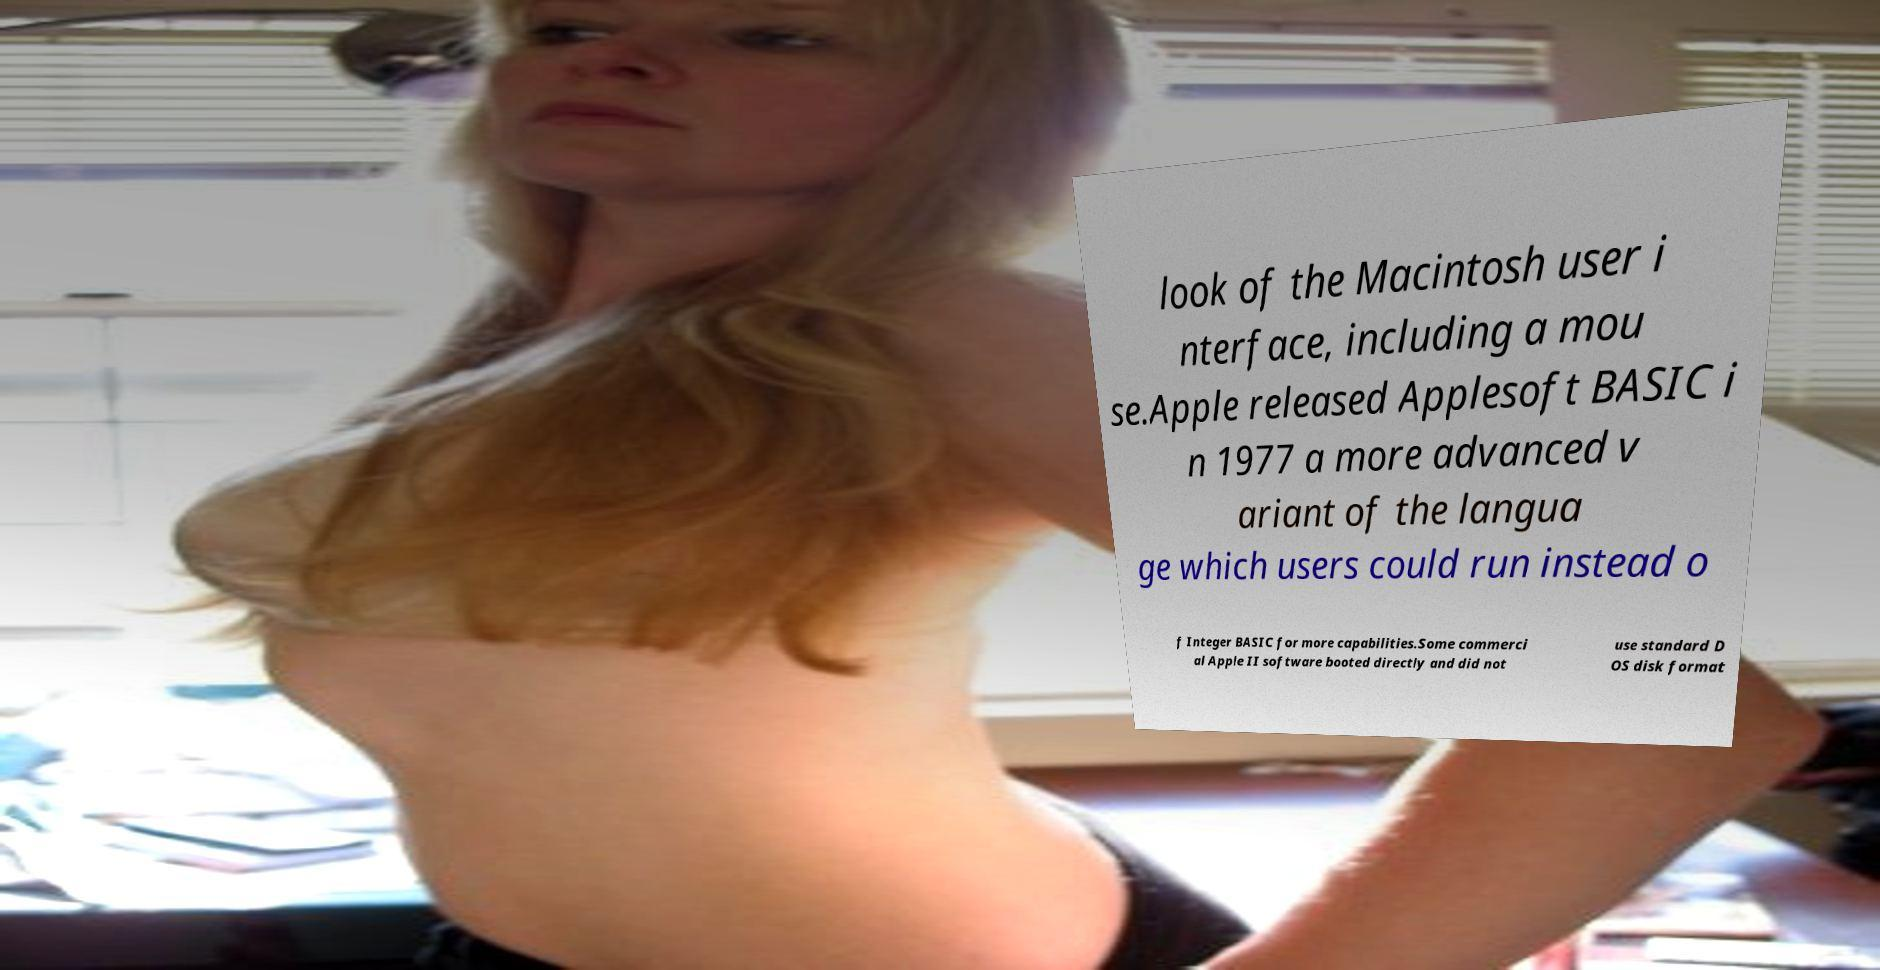For documentation purposes, I need the text within this image transcribed. Could you provide that? look of the Macintosh user i nterface, including a mou se.Apple released Applesoft BASIC i n 1977 a more advanced v ariant of the langua ge which users could run instead o f Integer BASIC for more capabilities.Some commerci al Apple II software booted directly and did not use standard D OS disk format 